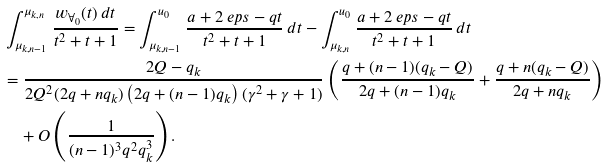Convert formula to latex. <formula><loc_0><loc_0><loc_500><loc_500>& \int _ { \mu _ { k , n - 1 } } ^ { \mu _ { k , n } } \frac { w _ { \AA _ { 0 } } ( t ) \, d t } { t ^ { 2 } + t + 1 } = \int _ { \mu _ { k , n - 1 } } ^ { u _ { 0 } } \frac { a + 2 \ e p s - q t } { t ^ { 2 } + t + 1 } \, d t - \int _ { \mu _ { k , n } } ^ { u _ { 0 } } \frac { a + 2 \ e p s - q t } { t ^ { 2 } + t + 1 } \, d t \\ & = \frac { 2 Q - q _ { k } } { 2 Q ^ { 2 } ( 2 q + n q _ { k } ) \left ( 2 q + ( n - 1 ) q _ { k } \right ) ( \gamma ^ { 2 } + \gamma + 1 ) } \left ( \frac { q + ( n - 1 ) ( q _ { k } - Q ) } { 2 q + ( n - 1 ) q _ { k } } + \frac { q + n ( q _ { k } - Q ) } { 2 q + n q _ { k } } \right ) \\ & \quad + O \left ( \frac { 1 } { ( n - 1 ) ^ { 3 } q ^ { 2 } q _ { k } ^ { 3 } } \right ) .</formula> 